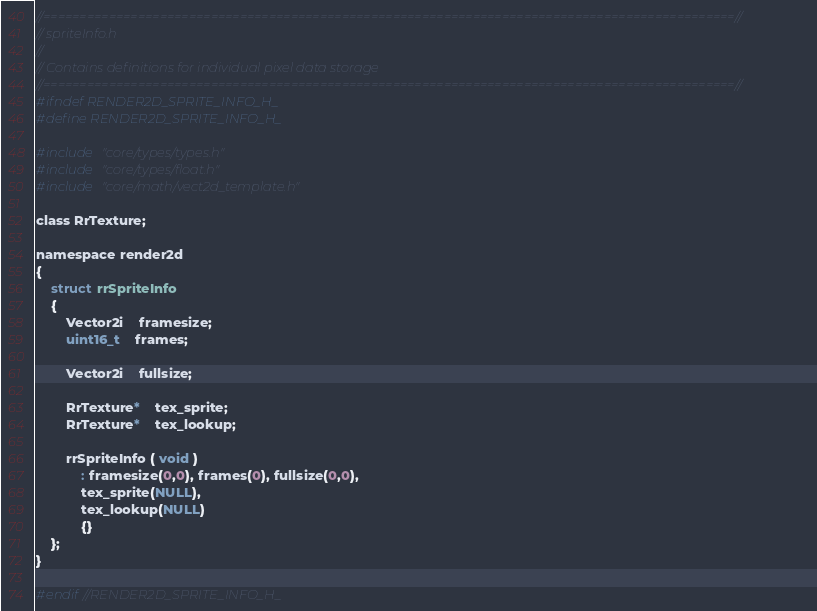<code> <loc_0><loc_0><loc_500><loc_500><_C_>//===============================================================================================//
// spriteInfo.h
//
// Contains definitions for individual pixel data storage
//===============================================================================================//
#ifndef RENDER2D_SPRITE_INFO_H_
#define RENDER2D_SPRITE_INFO_H_

#include "core/types/types.h"
#include "core/types/float.h"
#include "core/math/vect2d_template.h"

class RrTexture;

namespace render2d
{
	struct rrSpriteInfo
	{
		Vector2i	framesize;
		uint16_t	frames;

		Vector2i	fullsize;

		RrTexture*	tex_sprite;
		RrTexture*	tex_lookup;

		rrSpriteInfo ( void )
			: framesize(0,0), frames(0), fullsize(0,0),
			tex_sprite(NULL),
			tex_lookup(NULL)
			{}
	};
}

#endif//RENDER2D_SPRITE_INFO_H_</code> 